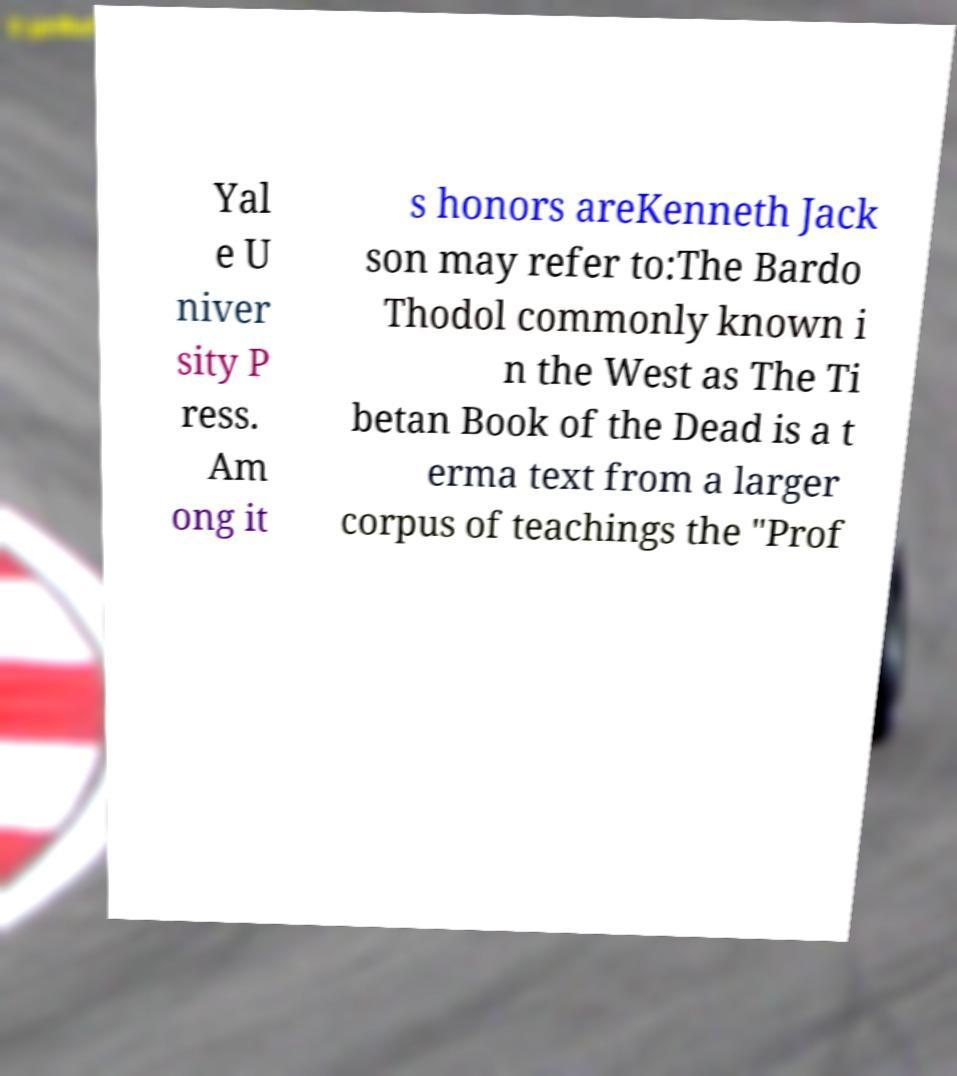For documentation purposes, I need the text within this image transcribed. Could you provide that? Yal e U niver sity P ress. Am ong it s honors areKenneth Jack son may refer to:The Bardo Thodol commonly known i n the West as The Ti betan Book of the Dead is a t erma text from a larger corpus of teachings the "Prof 